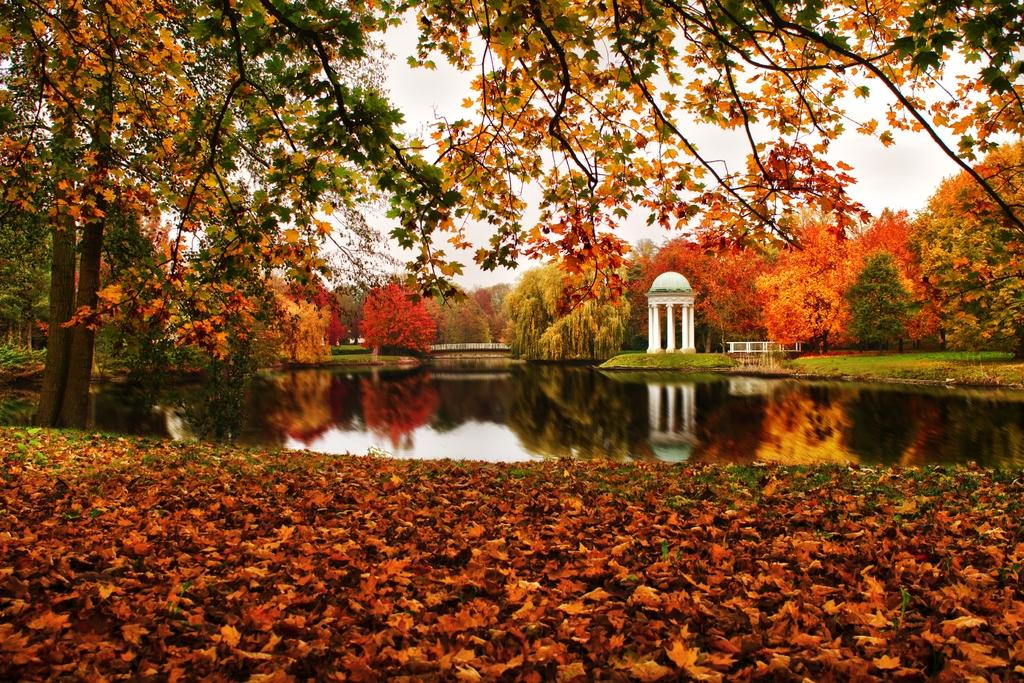What can be seen in the sky in the image? The sky is visible in the image. What type of vegetation is present in the image? There are trees in the image. What body of water is in the image? There is a pond in the image. What is on the ground in the image? Leaves are present on the ground in the image. What type of tail can be seen on the face of the person in the image? There is no person present in the image, and therefore no face or tail can be seen. 